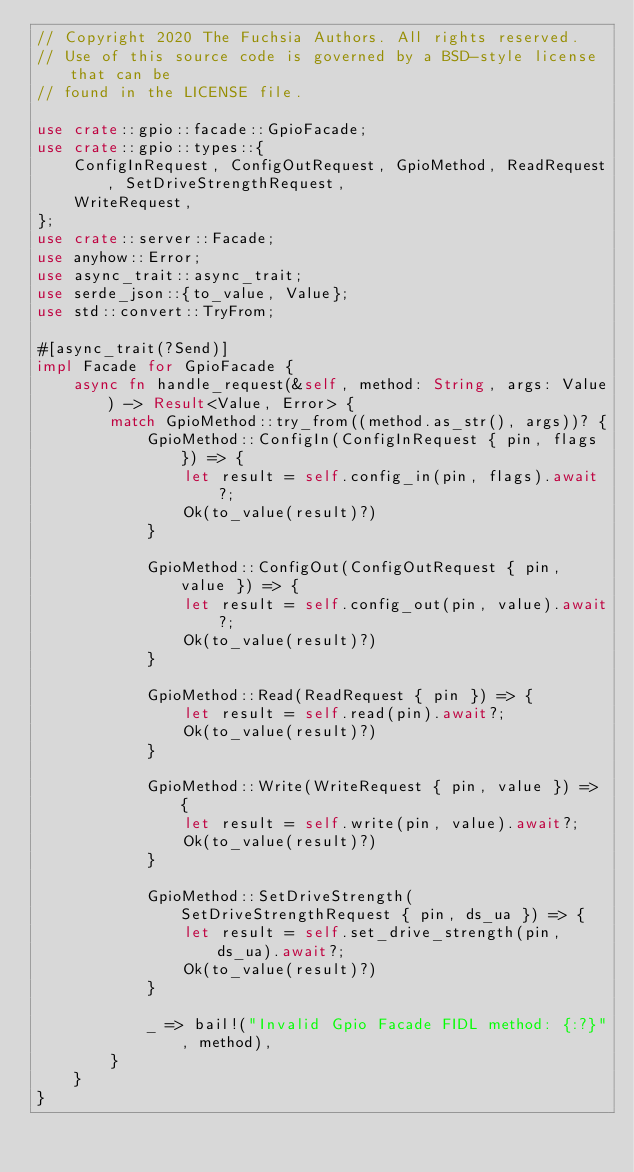<code> <loc_0><loc_0><loc_500><loc_500><_Rust_>// Copyright 2020 The Fuchsia Authors. All rights reserved.
// Use of this source code is governed by a BSD-style license that can be
// found in the LICENSE file.

use crate::gpio::facade::GpioFacade;
use crate::gpio::types::{
    ConfigInRequest, ConfigOutRequest, GpioMethod, ReadRequest, SetDriveStrengthRequest,
    WriteRequest,
};
use crate::server::Facade;
use anyhow::Error;
use async_trait::async_trait;
use serde_json::{to_value, Value};
use std::convert::TryFrom;

#[async_trait(?Send)]
impl Facade for GpioFacade {
    async fn handle_request(&self, method: String, args: Value) -> Result<Value, Error> {
        match GpioMethod::try_from((method.as_str(), args))? {
            GpioMethod::ConfigIn(ConfigInRequest { pin, flags }) => {
                let result = self.config_in(pin, flags).await?;
                Ok(to_value(result)?)
            }

            GpioMethod::ConfigOut(ConfigOutRequest { pin, value }) => {
                let result = self.config_out(pin, value).await?;
                Ok(to_value(result)?)
            }

            GpioMethod::Read(ReadRequest { pin }) => {
                let result = self.read(pin).await?;
                Ok(to_value(result)?)
            }

            GpioMethod::Write(WriteRequest { pin, value }) => {
                let result = self.write(pin, value).await?;
                Ok(to_value(result)?)
            }

            GpioMethod::SetDriveStrength(SetDriveStrengthRequest { pin, ds_ua }) => {
                let result = self.set_drive_strength(pin, ds_ua).await?;
                Ok(to_value(result)?)
            }

            _ => bail!("Invalid Gpio Facade FIDL method: {:?}", method),
        }
    }
}
</code> 